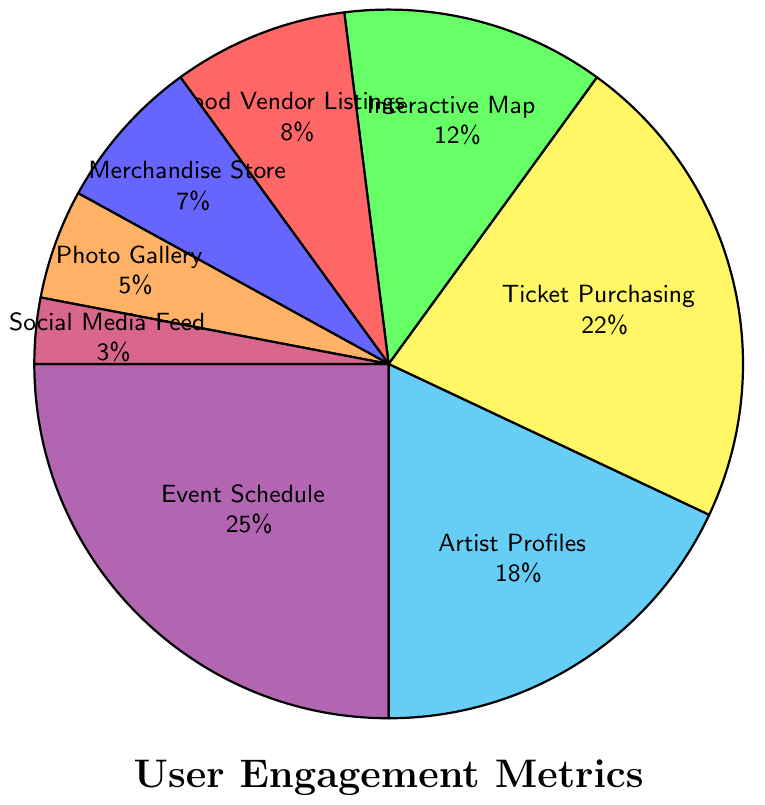What's the largest section in the pie chart? The largest section in the pie chart is represented by the largest slice. By looking at the figure, it's clear that the "Event Schedule" section, which accounts for 25% of the engagement, is the largest.
Answer: Event Schedule Which section has the least user engagement? The section with the smallest slice in the pie chart represents the least user engagement. From the chart, the "Social Media Feed" section is the smallest, comprising 3% of the engagement.
Answer: Social Media Feed What is the combined user engagement percentage of the "Food Vendor Listings" and "Merchandise Store" sections? To find the combined percentage, we add the engagement percentages of the two sections. For "Food Vendor Listings" (8%) and "Merchandise Store" (7%), the total is 8% + 7% = 15%.
Answer: 15% Which section has more engagement: "Artist Profiles" or "Interactive Map"? Comparing the slices for "Artist Profiles" and "Interactive Map", "Artist Profiles" has a larger slice with 18% compared to the 12% of "Interactive Map".
Answer: Artist Profiles What's the difference in engagement between the "Event Schedule" and "Ticket Purchasing" sections? The "Event Schedule" has 25% engagement, and the "Ticket Purchasing" has 22% engagement. The difference is 25% - 22% = 3%.
Answer: 3% Which section is represented by the red color in the pie chart? The color red corresponds to the section with 8% engagement in the chart, which is the "Food Vendor Listings".
Answer: Food Vendor Listings How many sections have an engagement percentage greater than 10%? By examining the pie chart, the sections with greater than 10% engagement are "Event Schedule" (25%), "Artist Profiles" (18%), "Ticket Purchasing" (22%), and "Interactive Map" (12%). There are four sections in total.
Answer: 4 Compare the engagement of "Photo Gallery" with "Social Media Feed". "Photo Gallery" has 5% engagement, whereas "Social Media Feed" has 3% engagement. Thus, "Photo Gallery" has more engagement than "Social Media Feed".
Answer: Photo Gallery What is the total engagement percentage of sections with less than 10% engagement? To find the total, we add the engagement percentages of sections with less than 10%. These sections are "Food Vendor Listings" (8%), "Merchandise Store" (7%), "Photo Gallery" (5%), and "Social Media Feed" (3%). The total is 8% + 7% + 5% + 3% = 23%.
Answer: 23% What's the combined engagement percentage of the top three most engaged sections? The top three most engaged sections are "Event Schedule" (25%), "Ticket Purchasing" (22%), and "Artist Profiles" (18%). The combined engagement is 25% + 22% + 18% = 65%.
Answer: 65% 